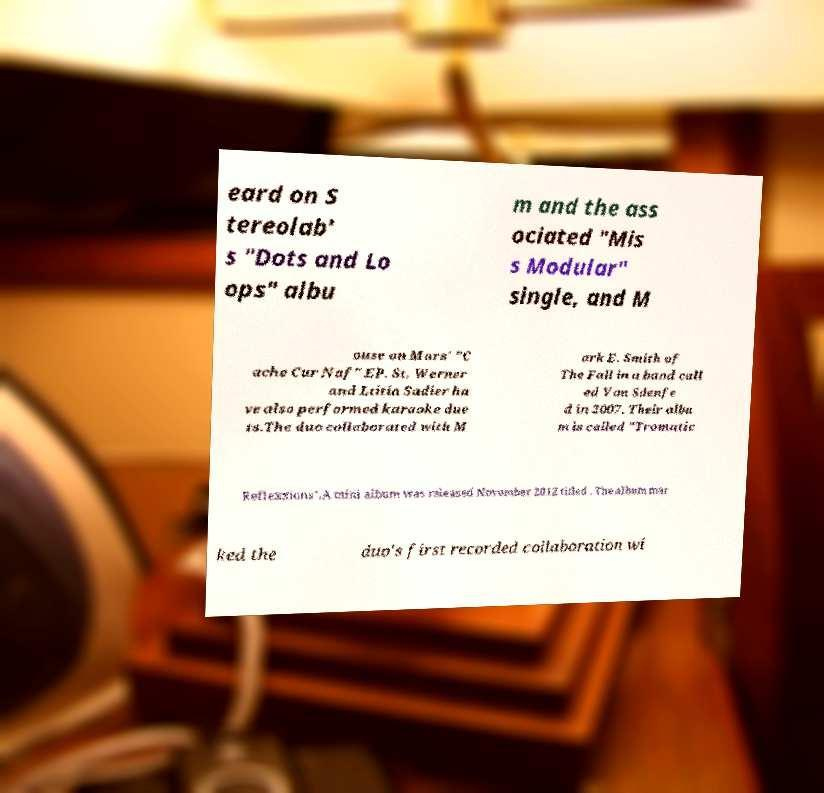I need the written content from this picture converted into text. Can you do that? eard on S tereolab' s "Dots and Lo ops" albu m and the ass ociated "Mis s Modular" single, and M ouse on Mars' "C ache Cur Naf" EP. St. Werner and Ltitia Sadier ha ve also performed karaoke due ts.The duo collaborated with M ark E. Smith of The Fall in a band call ed Von Sdenfe d in 2007. Their albu m is called "Tromatic Reflexxions".A mini album was released November 2012 titled . The album mar ked the duo's first recorded collaboration wi 